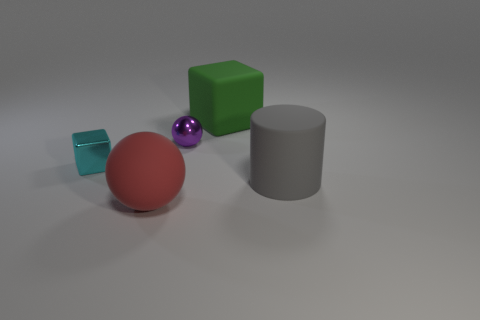Add 5 gray rubber things. How many objects exist? 10 Subtract all red matte objects. Subtract all big matte blocks. How many objects are left? 3 Add 2 red spheres. How many red spheres are left? 3 Add 5 small red cylinders. How many small red cylinders exist? 5 Subtract 0 green cylinders. How many objects are left? 5 Subtract all cylinders. How many objects are left? 4 Subtract all red cylinders. Subtract all purple blocks. How many cylinders are left? 1 